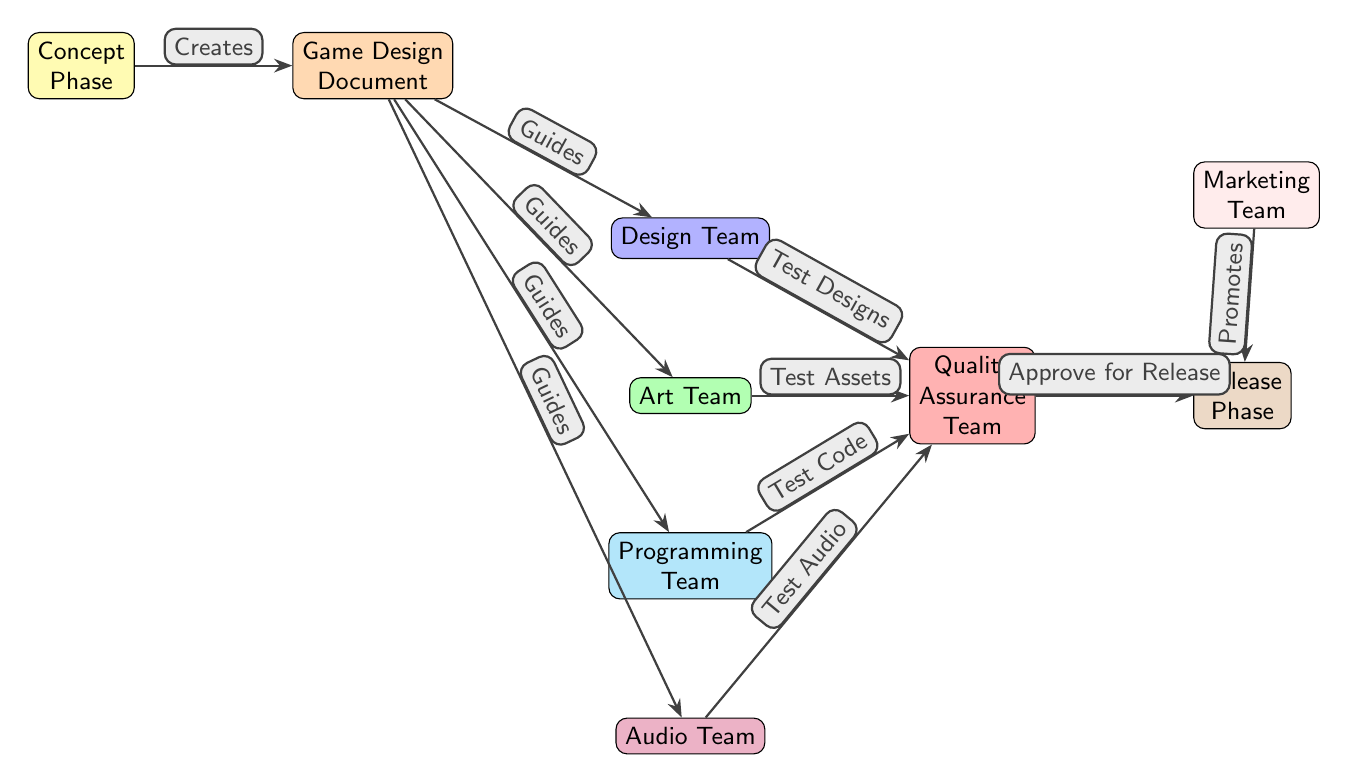What's the first phase in the diagram? The diagram starts with the "Concept Phase" node, which is the first element shown on the left.
Answer: Concept Phase How many teams are present in the diagram? Counting the distinct teams in the diagram, there are five teams: Design Team, Art Team, Programming Team, Audio Team, and Quality Assurance Team, leading to a total of six distinct nodes, including the Concept Phase.
Answer: Six What document does the Concept Phase create? The arrow from the "Concept Phase" to "Game Design Document" indicates that the Concept Phase leads to the creation of this document.
Answer: Game Design Document Which team is involved in testing designs? According to the diagram, the "Quality Assurance Team" is connected to the "Design Team" node, indicating their role in testing the designs created by this team.
Answer: Quality Assurance Team What does the Marketing Team do in the diagram? The arrow connects the "Marketing Team" to the "Release Phase" with the label "Promotes", showing that its role is to promote for the release phase.
Answer: Promotes What guides the Design, Art, Programming, and Audio teams? The central "Game Design Document" node guides the four teams, as indicated by the arrows pointing from it to each team, labeled as "Guides."
Answer: Game Design Document Which team is responsible for approving the release? The "Quality Assurance Team" is directly connected to the "Release Phase" with the label "Approve for Release", indicating it is responsible for this task.
Answer: Quality Assurance Team Which team tests the audio components? The "Audio Team" node shows it connects to the "Quality Assurance Team" with the label "Test Audio," indicating their responsibility for audio testing.
Answer: Quality Assurance Team What is the last phase in the diagram? The "Release Phase" is positioned at the end of the flow, indicating it is the final phase in the game development timeline represented in this diagram.
Answer: Release Phase 